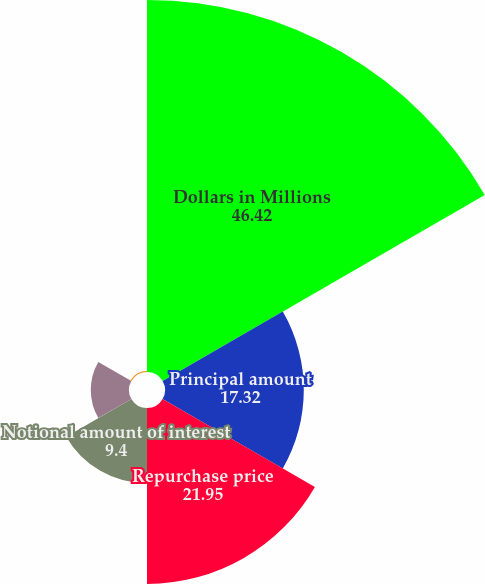Convert chart. <chart><loc_0><loc_0><loc_500><loc_500><pie_chart><fcel>Dollars in Millions<fcel>Principal amount<fcel>Repurchase price<fcel>Notional amount of interest<fcel>Swap termination proceeds<fcel>Total (gain)/loss<nl><fcel>46.42%<fcel>17.32%<fcel>21.95%<fcel>9.4%<fcel>4.77%<fcel>0.14%<nl></chart> 